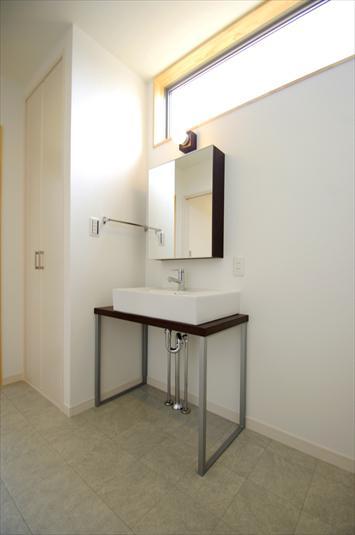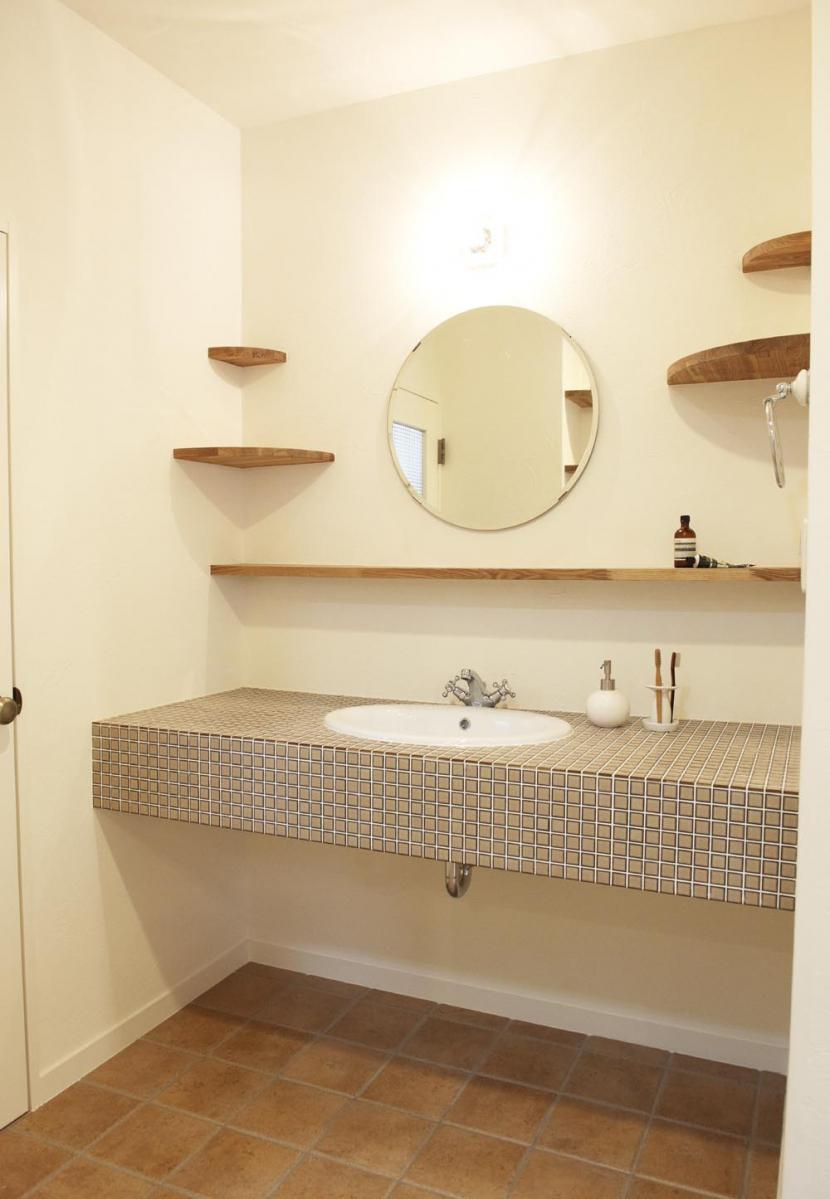The first image is the image on the left, the second image is the image on the right. Evaluate the accuracy of this statement regarding the images: "At least one of the images shows a washbasin on a wooden shelf.". Is it true? Answer yes or no. No. The first image is the image on the left, the second image is the image on the right. Assess this claim about the two images: "One sink is a rectangular bowl.". Correct or not? Answer yes or no. Yes. 